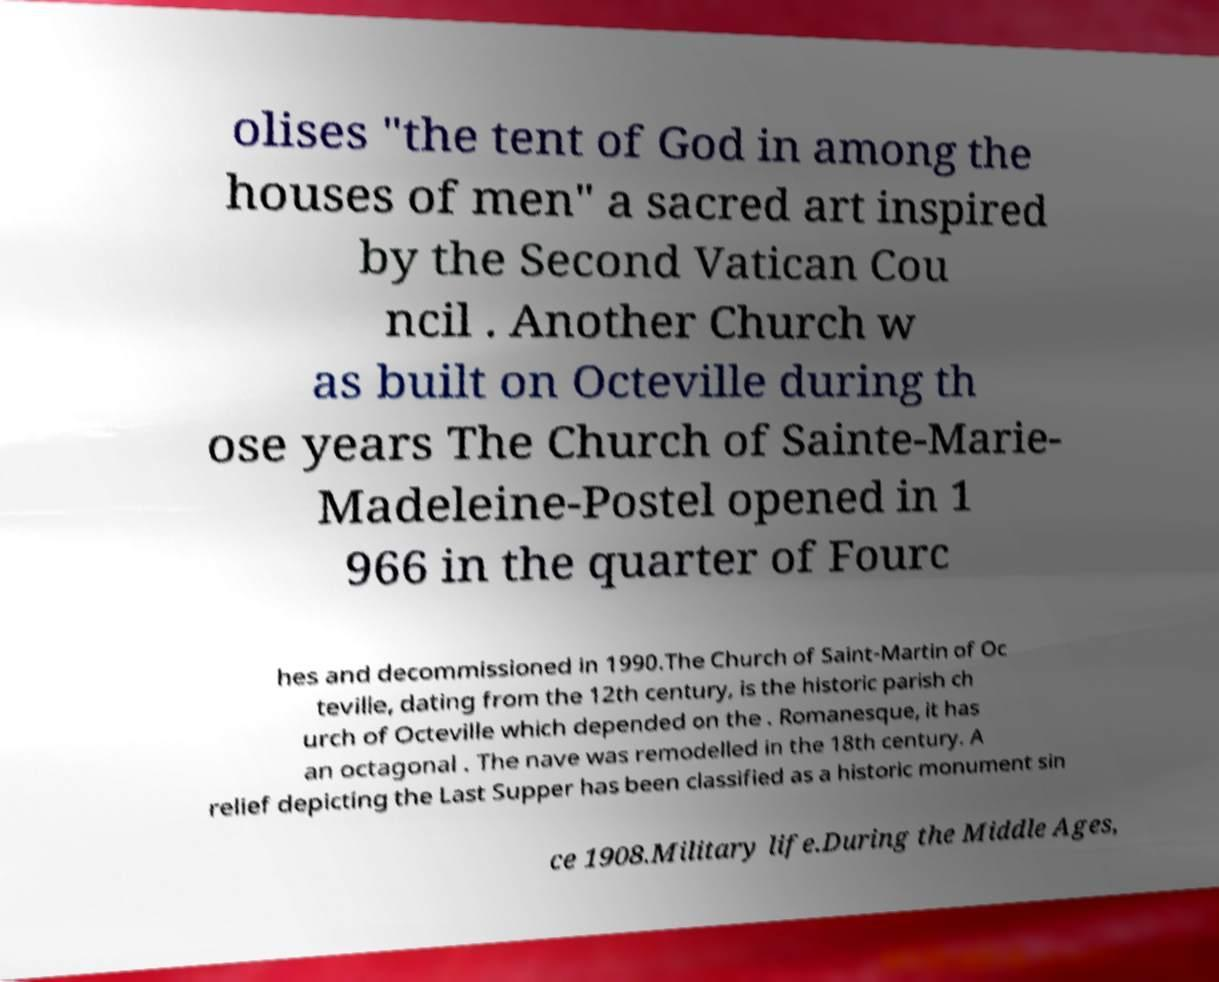I need the written content from this picture converted into text. Can you do that? olises "the tent of God in among the houses of men" a sacred art inspired by the Second Vatican Cou ncil . Another Church w as built on Octeville during th ose years The Church of Sainte-Marie- Madeleine-Postel opened in 1 966 in the quarter of Fourc hes and decommissioned in 1990.The Church of Saint-Martin of Oc teville, dating from the 12th century, is the historic parish ch urch of Octeville which depended on the . Romanesque, it has an octagonal . The nave was remodelled in the 18th century. A relief depicting the Last Supper has been classified as a historic monument sin ce 1908.Military life.During the Middle Ages, 